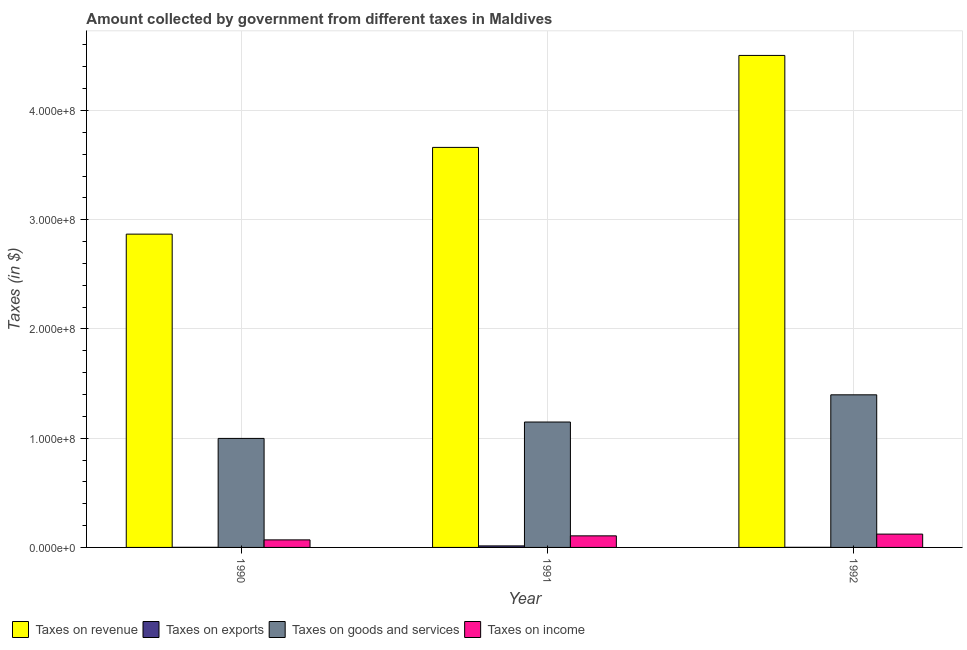How many different coloured bars are there?
Your answer should be compact. 4. How many bars are there on the 1st tick from the left?
Keep it short and to the point. 4. How many bars are there on the 3rd tick from the right?
Make the answer very short. 4. What is the amount collected as tax on exports in 1991?
Make the answer very short. 1.40e+06. Across all years, what is the maximum amount collected as tax on exports?
Your answer should be very brief. 1.40e+06. Across all years, what is the minimum amount collected as tax on goods?
Your answer should be compact. 9.98e+07. What is the total amount collected as tax on revenue in the graph?
Offer a very short reply. 1.10e+09. What is the difference between the amount collected as tax on income in 1990 and that in 1992?
Your answer should be compact. -5.30e+06. What is the difference between the amount collected as tax on income in 1991 and the amount collected as tax on revenue in 1990?
Make the answer very short. 3.70e+06. What is the average amount collected as tax on income per year?
Provide a short and direct response. 9.90e+06. In how many years, is the amount collected as tax on income greater than 80000000 $?
Make the answer very short. 0. Is the amount collected as tax on exports in 1990 less than that in 1991?
Your response must be concise. Yes. What is the difference between the highest and the second highest amount collected as tax on exports?
Offer a very short reply. 1.30e+06. What is the difference between the highest and the lowest amount collected as tax on revenue?
Give a very brief answer. 1.64e+08. In how many years, is the amount collected as tax on revenue greater than the average amount collected as tax on revenue taken over all years?
Offer a very short reply. 1. What does the 2nd bar from the left in 1991 represents?
Ensure brevity in your answer.  Taxes on exports. What does the 1st bar from the right in 1990 represents?
Make the answer very short. Taxes on income. Is it the case that in every year, the sum of the amount collected as tax on revenue and amount collected as tax on exports is greater than the amount collected as tax on goods?
Your answer should be very brief. Yes. How many bars are there?
Give a very brief answer. 12. Are all the bars in the graph horizontal?
Ensure brevity in your answer.  No. Are the values on the major ticks of Y-axis written in scientific E-notation?
Provide a short and direct response. Yes. How are the legend labels stacked?
Keep it short and to the point. Horizontal. What is the title of the graph?
Offer a terse response. Amount collected by government from different taxes in Maldives. Does "Secondary vocational" appear as one of the legend labels in the graph?
Your answer should be very brief. No. What is the label or title of the Y-axis?
Give a very brief answer. Taxes (in $). What is the Taxes (in $) in Taxes on revenue in 1990?
Give a very brief answer. 2.87e+08. What is the Taxes (in $) of Taxes on exports in 1990?
Offer a very short reply. 1.00e+05. What is the Taxes (in $) of Taxes on goods and services in 1990?
Ensure brevity in your answer.  9.98e+07. What is the Taxes (in $) of Taxes on income in 1990?
Give a very brief answer. 6.90e+06. What is the Taxes (in $) in Taxes on revenue in 1991?
Make the answer very short. 3.66e+08. What is the Taxes (in $) of Taxes on exports in 1991?
Provide a succinct answer. 1.40e+06. What is the Taxes (in $) in Taxes on goods and services in 1991?
Offer a very short reply. 1.15e+08. What is the Taxes (in $) of Taxes on income in 1991?
Provide a short and direct response. 1.06e+07. What is the Taxes (in $) in Taxes on revenue in 1992?
Make the answer very short. 4.50e+08. What is the Taxes (in $) in Taxes on goods and services in 1992?
Your answer should be compact. 1.40e+08. What is the Taxes (in $) of Taxes on income in 1992?
Keep it short and to the point. 1.22e+07. Across all years, what is the maximum Taxes (in $) in Taxes on revenue?
Your answer should be compact. 4.50e+08. Across all years, what is the maximum Taxes (in $) in Taxes on exports?
Your response must be concise. 1.40e+06. Across all years, what is the maximum Taxes (in $) in Taxes on goods and services?
Offer a very short reply. 1.40e+08. Across all years, what is the maximum Taxes (in $) in Taxes on income?
Keep it short and to the point. 1.22e+07. Across all years, what is the minimum Taxes (in $) in Taxes on revenue?
Your answer should be very brief. 2.87e+08. Across all years, what is the minimum Taxes (in $) of Taxes on goods and services?
Offer a terse response. 9.98e+07. Across all years, what is the minimum Taxes (in $) in Taxes on income?
Your answer should be very brief. 6.90e+06. What is the total Taxes (in $) in Taxes on revenue in the graph?
Keep it short and to the point. 1.10e+09. What is the total Taxes (in $) in Taxes on exports in the graph?
Your answer should be very brief. 1.60e+06. What is the total Taxes (in $) in Taxes on goods and services in the graph?
Your answer should be compact. 3.54e+08. What is the total Taxes (in $) of Taxes on income in the graph?
Offer a terse response. 2.97e+07. What is the difference between the Taxes (in $) of Taxes on revenue in 1990 and that in 1991?
Ensure brevity in your answer.  -7.94e+07. What is the difference between the Taxes (in $) in Taxes on exports in 1990 and that in 1991?
Your answer should be compact. -1.30e+06. What is the difference between the Taxes (in $) in Taxes on goods and services in 1990 and that in 1991?
Your response must be concise. -1.50e+07. What is the difference between the Taxes (in $) of Taxes on income in 1990 and that in 1991?
Your answer should be very brief. -3.70e+06. What is the difference between the Taxes (in $) in Taxes on revenue in 1990 and that in 1992?
Offer a terse response. -1.64e+08. What is the difference between the Taxes (in $) in Taxes on exports in 1990 and that in 1992?
Your answer should be very brief. 0. What is the difference between the Taxes (in $) of Taxes on goods and services in 1990 and that in 1992?
Ensure brevity in your answer.  -3.99e+07. What is the difference between the Taxes (in $) in Taxes on income in 1990 and that in 1992?
Ensure brevity in your answer.  -5.30e+06. What is the difference between the Taxes (in $) of Taxes on revenue in 1991 and that in 1992?
Make the answer very short. -8.42e+07. What is the difference between the Taxes (in $) of Taxes on exports in 1991 and that in 1992?
Provide a short and direct response. 1.30e+06. What is the difference between the Taxes (in $) in Taxes on goods and services in 1991 and that in 1992?
Provide a short and direct response. -2.49e+07. What is the difference between the Taxes (in $) in Taxes on income in 1991 and that in 1992?
Your answer should be compact. -1.60e+06. What is the difference between the Taxes (in $) of Taxes on revenue in 1990 and the Taxes (in $) of Taxes on exports in 1991?
Your answer should be very brief. 2.85e+08. What is the difference between the Taxes (in $) of Taxes on revenue in 1990 and the Taxes (in $) of Taxes on goods and services in 1991?
Provide a succinct answer. 1.72e+08. What is the difference between the Taxes (in $) of Taxes on revenue in 1990 and the Taxes (in $) of Taxes on income in 1991?
Provide a succinct answer. 2.76e+08. What is the difference between the Taxes (in $) in Taxes on exports in 1990 and the Taxes (in $) in Taxes on goods and services in 1991?
Offer a terse response. -1.15e+08. What is the difference between the Taxes (in $) in Taxes on exports in 1990 and the Taxes (in $) in Taxes on income in 1991?
Offer a very short reply. -1.05e+07. What is the difference between the Taxes (in $) in Taxes on goods and services in 1990 and the Taxes (in $) in Taxes on income in 1991?
Give a very brief answer. 8.92e+07. What is the difference between the Taxes (in $) in Taxes on revenue in 1990 and the Taxes (in $) in Taxes on exports in 1992?
Provide a short and direct response. 2.87e+08. What is the difference between the Taxes (in $) in Taxes on revenue in 1990 and the Taxes (in $) in Taxes on goods and services in 1992?
Make the answer very short. 1.47e+08. What is the difference between the Taxes (in $) in Taxes on revenue in 1990 and the Taxes (in $) in Taxes on income in 1992?
Provide a short and direct response. 2.75e+08. What is the difference between the Taxes (in $) of Taxes on exports in 1990 and the Taxes (in $) of Taxes on goods and services in 1992?
Offer a very short reply. -1.40e+08. What is the difference between the Taxes (in $) in Taxes on exports in 1990 and the Taxes (in $) in Taxes on income in 1992?
Your answer should be compact. -1.21e+07. What is the difference between the Taxes (in $) of Taxes on goods and services in 1990 and the Taxes (in $) of Taxes on income in 1992?
Give a very brief answer. 8.76e+07. What is the difference between the Taxes (in $) of Taxes on revenue in 1991 and the Taxes (in $) of Taxes on exports in 1992?
Keep it short and to the point. 3.66e+08. What is the difference between the Taxes (in $) in Taxes on revenue in 1991 and the Taxes (in $) in Taxes on goods and services in 1992?
Your answer should be compact. 2.26e+08. What is the difference between the Taxes (in $) in Taxes on revenue in 1991 and the Taxes (in $) in Taxes on income in 1992?
Give a very brief answer. 3.54e+08. What is the difference between the Taxes (in $) of Taxes on exports in 1991 and the Taxes (in $) of Taxes on goods and services in 1992?
Keep it short and to the point. -1.38e+08. What is the difference between the Taxes (in $) of Taxes on exports in 1991 and the Taxes (in $) of Taxes on income in 1992?
Make the answer very short. -1.08e+07. What is the difference between the Taxes (in $) in Taxes on goods and services in 1991 and the Taxes (in $) in Taxes on income in 1992?
Offer a very short reply. 1.03e+08. What is the average Taxes (in $) of Taxes on revenue per year?
Provide a short and direct response. 3.68e+08. What is the average Taxes (in $) of Taxes on exports per year?
Ensure brevity in your answer.  5.33e+05. What is the average Taxes (in $) of Taxes on goods and services per year?
Your response must be concise. 1.18e+08. What is the average Taxes (in $) of Taxes on income per year?
Provide a short and direct response. 9.90e+06. In the year 1990, what is the difference between the Taxes (in $) of Taxes on revenue and Taxes (in $) of Taxes on exports?
Provide a short and direct response. 2.87e+08. In the year 1990, what is the difference between the Taxes (in $) in Taxes on revenue and Taxes (in $) in Taxes on goods and services?
Provide a short and direct response. 1.87e+08. In the year 1990, what is the difference between the Taxes (in $) of Taxes on revenue and Taxes (in $) of Taxes on income?
Provide a succinct answer. 2.80e+08. In the year 1990, what is the difference between the Taxes (in $) of Taxes on exports and Taxes (in $) of Taxes on goods and services?
Provide a succinct answer. -9.97e+07. In the year 1990, what is the difference between the Taxes (in $) of Taxes on exports and Taxes (in $) of Taxes on income?
Your answer should be very brief. -6.80e+06. In the year 1990, what is the difference between the Taxes (in $) of Taxes on goods and services and Taxes (in $) of Taxes on income?
Make the answer very short. 9.29e+07. In the year 1991, what is the difference between the Taxes (in $) of Taxes on revenue and Taxes (in $) of Taxes on exports?
Ensure brevity in your answer.  3.65e+08. In the year 1991, what is the difference between the Taxes (in $) in Taxes on revenue and Taxes (in $) in Taxes on goods and services?
Offer a terse response. 2.51e+08. In the year 1991, what is the difference between the Taxes (in $) in Taxes on revenue and Taxes (in $) in Taxes on income?
Provide a short and direct response. 3.56e+08. In the year 1991, what is the difference between the Taxes (in $) in Taxes on exports and Taxes (in $) in Taxes on goods and services?
Your answer should be compact. -1.13e+08. In the year 1991, what is the difference between the Taxes (in $) of Taxes on exports and Taxes (in $) of Taxes on income?
Your response must be concise. -9.20e+06. In the year 1991, what is the difference between the Taxes (in $) of Taxes on goods and services and Taxes (in $) of Taxes on income?
Offer a very short reply. 1.04e+08. In the year 1992, what is the difference between the Taxes (in $) of Taxes on revenue and Taxes (in $) of Taxes on exports?
Ensure brevity in your answer.  4.50e+08. In the year 1992, what is the difference between the Taxes (in $) of Taxes on revenue and Taxes (in $) of Taxes on goods and services?
Your answer should be compact. 3.11e+08. In the year 1992, what is the difference between the Taxes (in $) of Taxes on revenue and Taxes (in $) of Taxes on income?
Keep it short and to the point. 4.38e+08. In the year 1992, what is the difference between the Taxes (in $) in Taxes on exports and Taxes (in $) in Taxes on goods and services?
Your response must be concise. -1.40e+08. In the year 1992, what is the difference between the Taxes (in $) of Taxes on exports and Taxes (in $) of Taxes on income?
Ensure brevity in your answer.  -1.21e+07. In the year 1992, what is the difference between the Taxes (in $) in Taxes on goods and services and Taxes (in $) in Taxes on income?
Offer a very short reply. 1.28e+08. What is the ratio of the Taxes (in $) in Taxes on revenue in 1990 to that in 1991?
Provide a short and direct response. 0.78. What is the ratio of the Taxes (in $) in Taxes on exports in 1990 to that in 1991?
Your answer should be compact. 0.07. What is the ratio of the Taxes (in $) in Taxes on goods and services in 1990 to that in 1991?
Make the answer very short. 0.87. What is the ratio of the Taxes (in $) of Taxes on income in 1990 to that in 1991?
Provide a succinct answer. 0.65. What is the ratio of the Taxes (in $) in Taxes on revenue in 1990 to that in 1992?
Offer a very short reply. 0.64. What is the ratio of the Taxes (in $) in Taxes on goods and services in 1990 to that in 1992?
Make the answer very short. 0.71. What is the ratio of the Taxes (in $) of Taxes on income in 1990 to that in 1992?
Your answer should be compact. 0.57. What is the ratio of the Taxes (in $) of Taxes on revenue in 1991 to that in 1992?
Your answer should be compact. 0.81. What is the ratio of the Taxes (in $) in Taxes on exports in 1991 to that in 1992?
Your answer should be compact. 14. What is the ratio of the Taxes (in $) in Taxes on goods and services in 1991 to that in 1992?
Provide a short and direct response. 0.82. What is the ratio of the Taxes (in $) of Taxes on income in 1991 to that in 1992?
Ensure brevity in your answer.  0.87. What is the difference between the highest and the second highest Taxes (in $) in Taxes on revenue?
Offer a terse response. 8.42e+07. What is the difference between the highest and the second highest Taxes (in $) of Taxes on exports?
Make the answer very short. 1.30e+06. What is the difference between the highest and the second highest Taxes (in $) in Taxes on goods and services?
Keep it short and to the point. 2.49e+07. What is the difference between the highest and the second highest Taxes (in $) of Taxes on income?
Provide a short and direct response. 1.60e+06. What is the difference between the highest and the lowest Taxes (in $) in Taxes on revenue?
Your answer should be compact. 1.64e+08. What is the difference between the highest and the lowest Taxes (in $) of Taxes on exports?
Your answer should be very brief. 1.30e+06. What is the difference between the highest and the lowest Taxes (in $) of Taxes on goods and services?
Give a very brief answer. 3.99e+07. What is the difference between the highest and the lowest Taxes (in $) of Taxes on income?
Offer a terse response. 5.30e+06. 